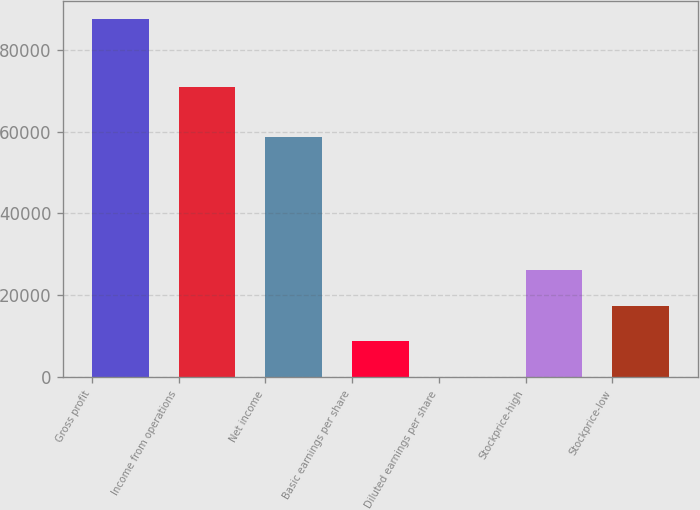<chart> <loc_0><loc_0><loc_500><loc_500><bar_chart><fcel>Gross profit<fcel>Income from operations<fcel>Net income<fcel>Basic earnings per share<fcel>Diluted earnings per share<fcel>Stockprice-high<fcel>Stockprice-low<nl><fcel>87538<fcel>70799<fcel>58683<fcel>8754.31<fcel>0.57<fcel>26261.8<fcel>17508<nl></chart> 